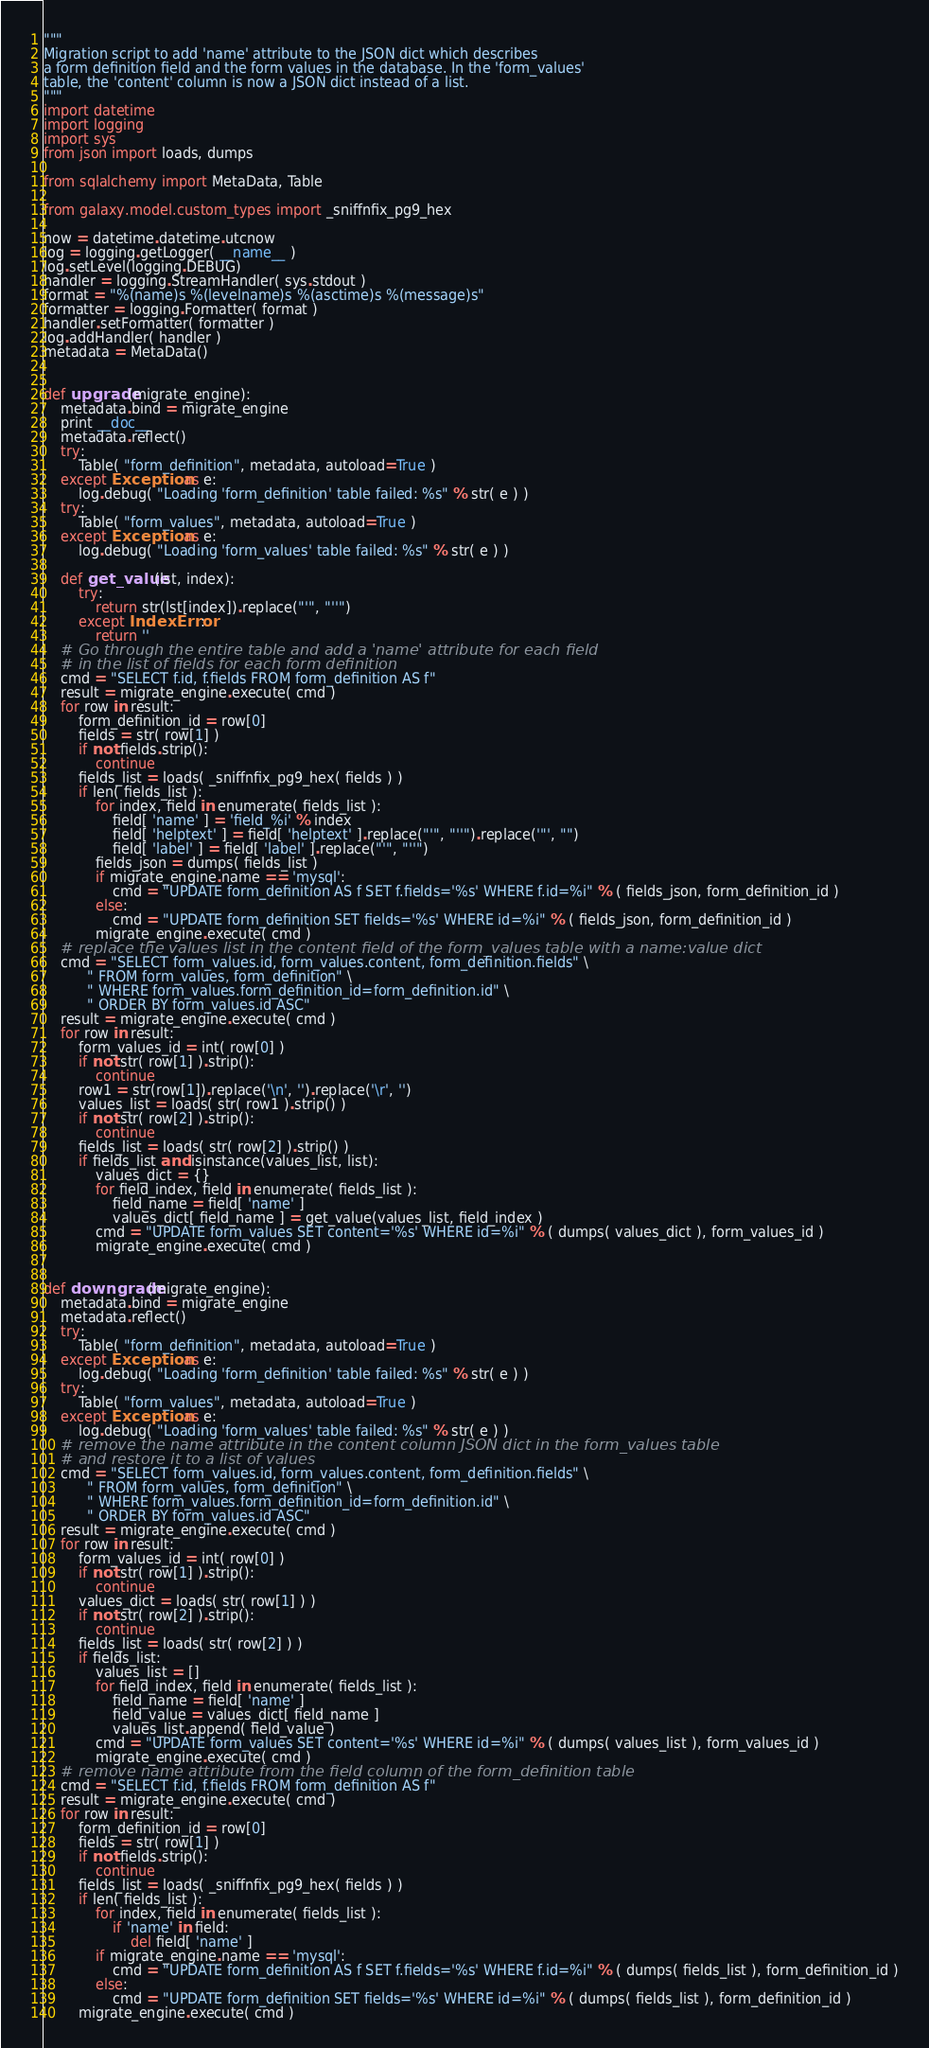<code> <loc_0><loc_0><loc_500><loc_500><_Python_>"""
Migration script to add 'name' attribute to the JSON dict which describes
a form definition field and the form values in the database. In the 'form_values'
table, the 'content' column is now a JSON dict instead of a list.
"""
import datetime
import logging
import sys
from json import loads, dumps

from sqlalchemy import MetaData, Table

from galaxy.model.custom_types import _sniffnfix_pg9_hex

now = datetime.datetime.utcnow
log = logging.getLogger( __name__ )
log.setLevel(logging.DEBUG)
handler = logging.StreamHandler( sys.stdout )
format = "%(name)s %(levelname)s %(asctime)s %(message)s"
formatter = logging.Formatter( format )
handler.setFormatter( formatter )
log.addHandler( handler )
metadata = MetaData()


def upgrade(migrate_engine):
    metadata.bind = migrate_engine
    print __doc__
    metadata.reflect()
    try:
        Table( "form_definition", metadata, autoload=True )
    except Exception as e:
        log.debug( "Loading 'form_definition' table failed: %s" % str( e ) )
    try:
        Table( "form_values", metadata, autoload=True )
    except Exception as e:
        log.debug( "Loading 'form_values' table failed: %s" % str( e ) )

    def get_value(lst, index):
        try:
            return str(lst[index]).replace("'", "''")
        except IndexError:
            return ''
    # Go through the entire table and add a 'name' attribute for each field
    # in the list of fields for each form definition
    cmd = "SELECT f.id, f.fields FROM form_definition AS f"
    result = migrate_engine.execute( cmd )
    for row in result:
        form_definition_id = row[0]
        fields = str( row[1] )
        if not fields.strip():
            continue
        fields_list = loads( _sniffnfix_pg9_hex( fields ) )
        if len( fields_list ):
            for index, field in enumerate( fields_list ):
                field[ 'name' ] = 'field_%i' % index
                field[ 'helptext' ] = field[ 'helptext' ].replace("'", "''").replace('"', "")
                field[ 'label' ] = field[ 'label' ].replace("'", "''")
            fields_json = dumps( fields_list )
            if migrate_engine.name == 'mysql':
                cmd = "UPDATE form_definition AS f SET f.fields='%s' WHERE f.id=%i" % ( fields_json, form_definition_id )
            else:
                cmd = "UPDATE form_definition SET fields='%s' WHERE id=%i" % ( fields_json, form_definition_id )
            migrate_engine.execute( cmd )
    # replace the values list in the content field of the form_values table with a name:value dict
    cmd = "SELECT form_values.id, form_values.content, form_definition.fields" \
          " FROM form_values, form_definition" \
          " WHERE form_values.form_definition_id=form_definition.id" \
          " ORDER BY form_values.id ASC"
    result = migrate_engine.execute( cmd )
    for row in result:
        form_values_id = int( row[0] )
        if not str( row[1] ).strip():
            continue
        row1 = str(row[1]).replace('\n', '').replace('\r', '')
        values_list = loads( str( row1 ).strip() )
        if not str( row[2] ).strip():
            continue
        fields_list = loads( str( row[2] ).strip() )
        if fields_list and isinstance(values_list, list):
            values_dict = {}
            for field_index, field in enumerate( fields_list ):
                field_name = field[ 'name' ]
                values_dict[ field_name ] = get_value(values_list, field_index )
            cmd = "UPDATE form_values SET content='%s' WHERE id=%i" % ( dumps( values_dict ), form_values_id )
            migrate_engine.execute( cmd )


def downgrade(migrate_engine):
    metadata.bind = migrate_engine
    metadata.reflect()
    try:
        Table( "form_definition", metadata, autoload=True )
    except Exception as e:
        log.debug( "Loading 'form_definition' table failed: %s" % str( e ) )
    try:
        Table( "form_values", metadata, autoload=True )
    except Exception as e:
        log.debug( "Loading 'form_values' table failed: %s" % str( e ) )
    # remove the name attribute in the content column JSON dict in the form_values table
    # and restore it to a list of values
    cmd = "SELECT form_values.id, form_values.content, form_definition.fields" \
          " FROM form_values, form_definition" \
          " WHERE form_values.form_definition_id=form_definition.id" \
          " ORDER BY form_values.id ASC"
    result = migrate_engine.execute( cmd )
    for row in result:
        form_values_id = int( row[0] )
        if not str( row[1] ).strip():
            continue
        values_dict = loads( str( row[1] ) )
        if not str( row[2] ).strip():
            continue
        fields_list = loads( str( row[2] ) )
        if fields_list:
            values_list = []
            for field_index, field in enumerate( fields_list ):
                field_name = field[ 'name' ]
                field_value = values_dict[ field_name ]
                values_list.append( field_value )
            cmd = "UPDATE form_values SET content='%s' WHERE id=%i" % ( dumps( values_list ), form_values_id )
            migrate_engine.execute( cmd )
    # remove name attribute from the field column of the form_definition table
    cmd = "SELECT f.id, f.fields FROM form_definition AS f"
    result = migrate_engine.execute( cmd )
    for row in result:
        form_definition_id = row[0]
        fields = str( row[1] )
        if not fields.strip():
            continue
        fields_list = loads( _sniffnfix_pg9_hex( fields ) )
        if len( fields_list ):
            for index, field in enumerate( fields_list ):
                if 'name' in field:
                    del field[ 'name' ]
            if migrate_engine.name == 'mysql':
                cmd = "UPDATE form_definition AS f SET f.fields='%s' WHERE f.id=%i" % ( dumps( fields_list ), form_definition_id )
            else:
                cmd = "UPDATE form_definition SET fields='%s' WHERE id=%i" % ( dumps( fields_list ), form_definition_id )
        migrate_engine.execute( cmd )
</code> 